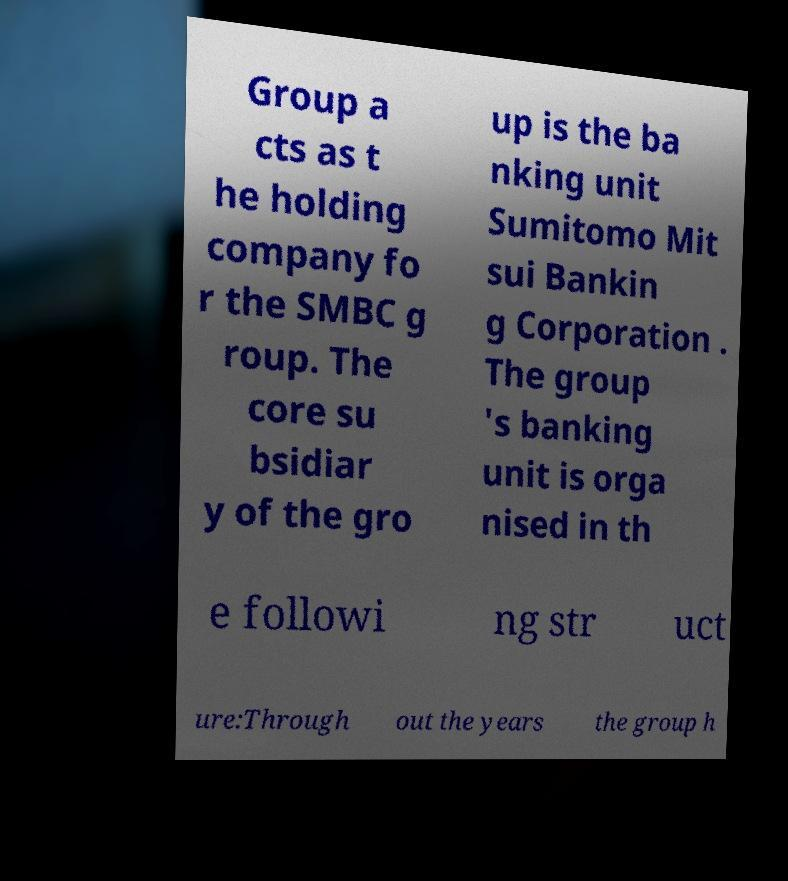Please identify and transcribe the text found in this image. Group a cts as t he holding company fo r the SMBC g roup. The core su bsidiar y of the gro up is the ba nking unit Sumitomo Mit sui Bankin g Corporation . The group 's banking unit is orga nised in th e followi ng str uct ure:Through out the years the group h 